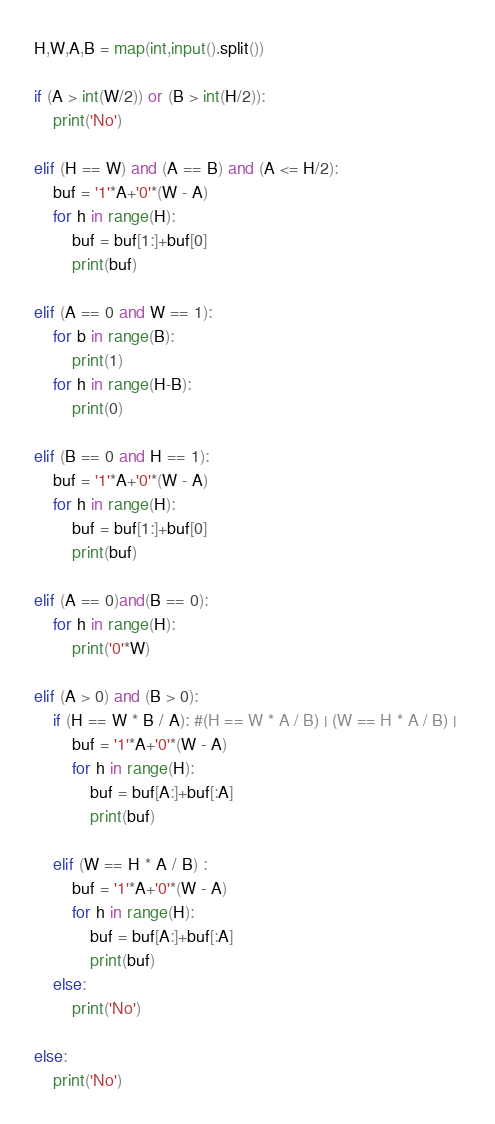Convert code to text. <code><loc_0><loc_0><loc_500><loc_500><_Python_>H,W,A,B = map(int,input().split())

if (A > int(W/2)) or (B > int(H/2)):
    print('No')

elif (H == W) and (A == B) and (A <= H/2):
    buf = '1'*A+'0'*(W - A)
    for h in range(H):
        buf = buf[1:]+buf[0]
        print(buf)

elif (A == 0 and W == 1):
    for b in range(B):
        print(1)
    for h in range(H-B):
        print(0)
        
elif (B == 0 and H == 1):
    buf = '1'*A+'0'*(W - A)
    for h in range(H):
        buf = buf[1:]+buf[0]
        print(buf)
        
elif (A == 0)and(B == 0):
    for h in range(H):
        print('0'*W)

elif (A > 0) and (B > 0):
    if (H == W * B / A): #(H == W * A / B) | (W == H * A / B) | 
        buf = '1'*A+'0'*(W - A)
        for h in range(H):
            buf = buf[A:]+buf[:A]
            print(buf)

    elif (W == H * A / B) :
        buf = '1'*A+'0'*(W - A)
        for h in range(H):
            buf = buf[A:]+buf[:A]
            print(buf)
    else:
        print('No')
        
else:
    print('No')</code> 